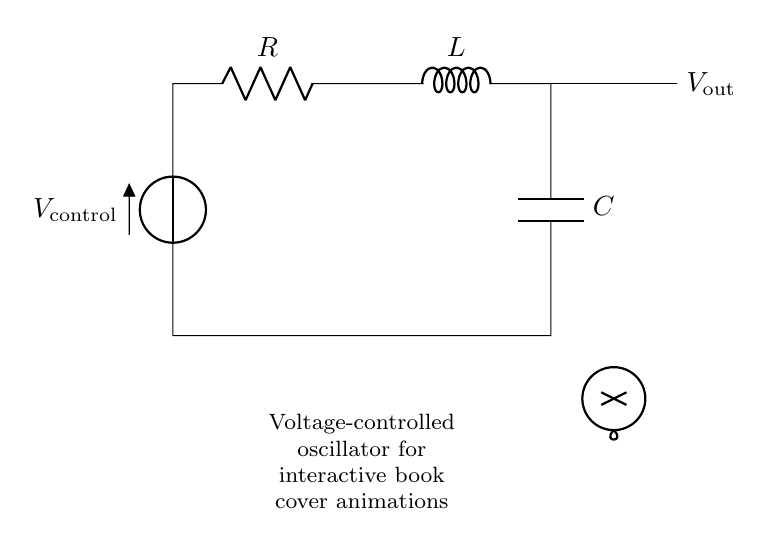What is the voltage source labeled as? The voltage source in the circuit is labeled as V_control, indicating it is controlled voltage.
Answer: V_control What components are used in this circuit? The circuit contains a resistor, inductor, and capacitor, represented by R, L, and C respectively.
Answer: Resistor, inductor, capacitor Where is the output voltage taken from? The output voltage V_out is taken from the connection following the inductor and the capacitor at the right side of the circuit.
Answer: After L and C How does the circuit function as an oscillator? The combination of resistor, inductor, and capacitor creates a frequency-dependent response, allowing the circuit to oscillate when driven by the control voltage.
Answer: It oscillates due to RLC What is the purpose of the voltage-controlled aspect? The voltage-controlled function allows the frequency and amplitude of the oscillation to be adjusted by varying the control voltage V_control.
Answer: It adjusts the frequency What type of oscillator is represented in this circuit? This circuit represents a voltage-controlled oscillator, which is specifically designed for applications requiring frequency modulation.
Answer: Voltage-controlled oscillator What role does the inductor play in this circuit? The inductor stores energy in a magnetic field and contributes to the oscillatory behavior along with the capacitor in this RLC circuit.
Answer: It stores energy 